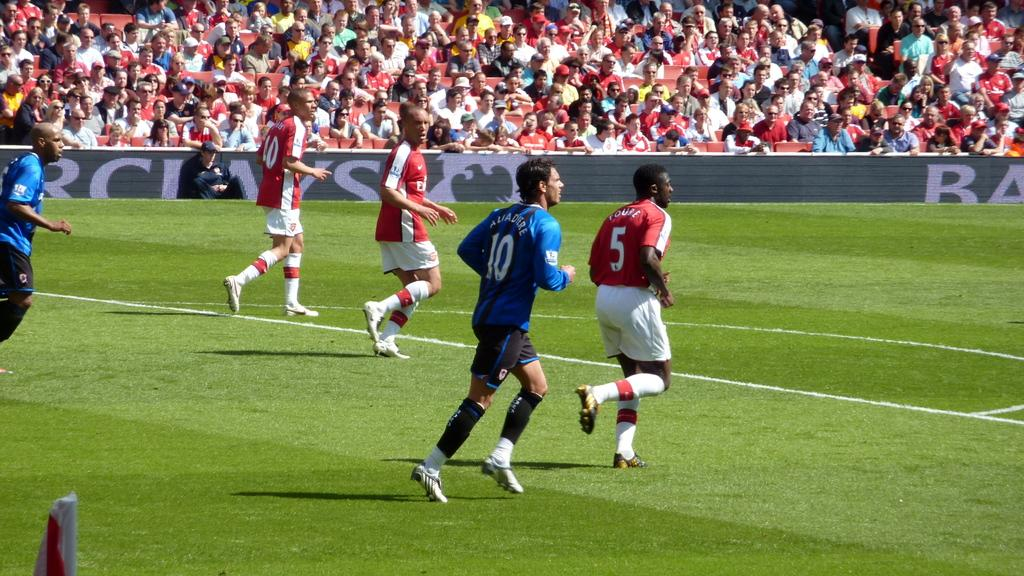What are the people in the image doing? The people in the image are playing a game. What type of surface is visible at the bottom of the image? There is grass at the bottom of the image. What can be seen in the background of the image? There is a crowd sitting in the background of the image, and a board is also visible. Can you see any needles being used by the people playing the game in the image? No, there are no needles present in the image. Is there a boat visible in the image? No, there is no boat present in the image. 